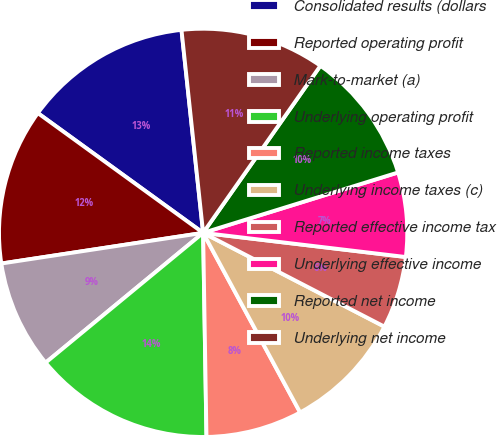<chart> <loc_0><loc_0><loc_500><loc_500><pie_chart><fcel>Consolidated results (dollars<fcel>Reported operating profit<fcel>Mark-to-market (a)<fcel>Underlying operating profit<fcel>Reported income taxes<fcel>Underlying income taxes (c)<fcel>Reported effective income tax<fcel>Underlying effective income<fcel>Reported net income<fcel>Underlying net income<nl><fcel>13.33%<fcel>12.38%<fcel>8.57%<fcel>14.29%<fcel>7.62%<fcel>9.52%<fcel>5.71%<fcel>6.67%<fcel>10.48%<fcel>11.43%<nl></chart> 